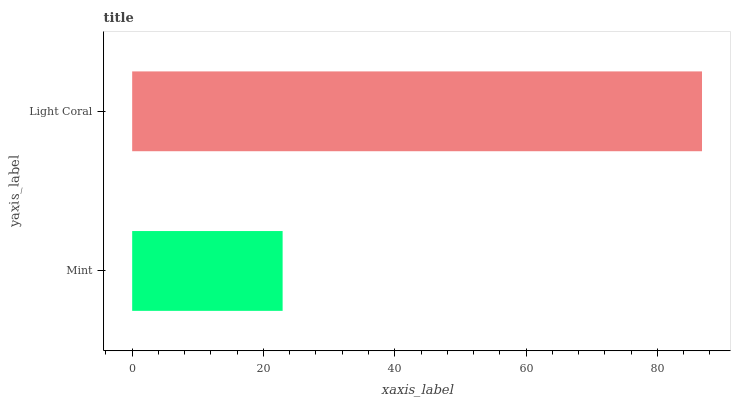Is Mint the minimum?
Answer yes or no. Yes. Is Light Coral the maximum?
Answer yes or no. Yes. Is Light Coral the minimum?
Answer yes or no. No. Is Light Coral greater than Mint?
Answer yes or no. Yes. Is Mint less than Light Coral?
Answer yes or no. Yes. Is Mint greater than Light Coral?
Answer yes or no. No. Is Light Coral less than Mint?
Answer yes or no. No. Is Light Coral the high median?
Answer yes or no. Yes. Is Mint the low median?
Answer yes or no. Yes. Is Mint the high median?
Answer yes or no. No. Is Light Coral the low median?
Answer yes or no. No. 